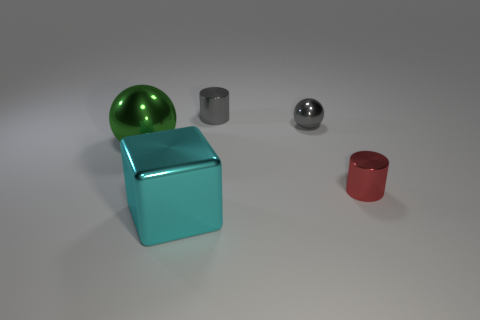Add 3 cyan shiny blocks. How many objects exist? 8 Subtract all blocks. How many objects are left? 4 Subtract all big shiny objects. Subtract all large blocks. How many objects are left? 2 Add 2 small balls. How many small balls are left? 3 Add 5 blocks. How many blocks exist? 6 Subtract 0 blue cylinders. How many objects are left? 5 